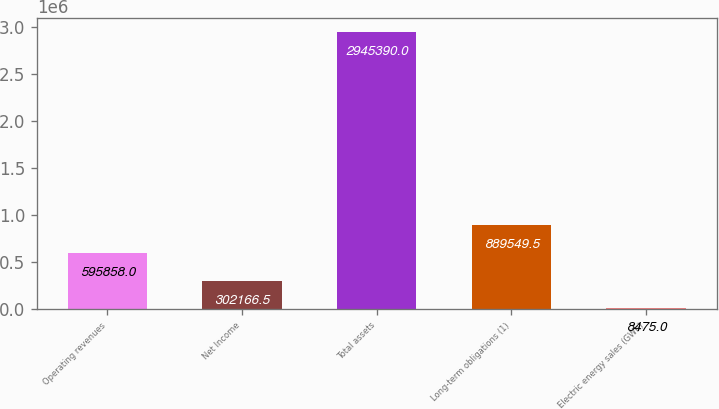Convert chart. <chart><loc_0><loc_0><loc_500><loc_500><bar_chart><fcel>Operating revenues<fcel>Net Income<fcel>Total assets<fcel>Long-term obligations (1)<fcel>Electric energy sales (GWh)<nl><fcel>595858<fcel>302166<fcel>2.94539e+06<fcel>889550<fcel>8475<nl></chart> 